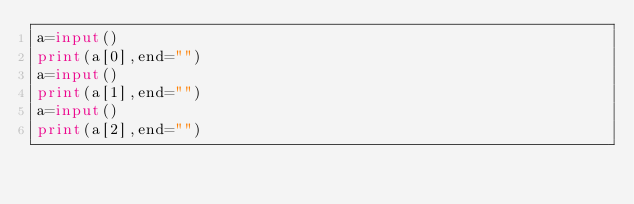<code> <loc_0><loc_0><loc_500><loc_500><_Python_>a=input()
print(a[0],end="")
a=input()
print(a[1],end="")
a=input()
print(a[2],end="")</code> 